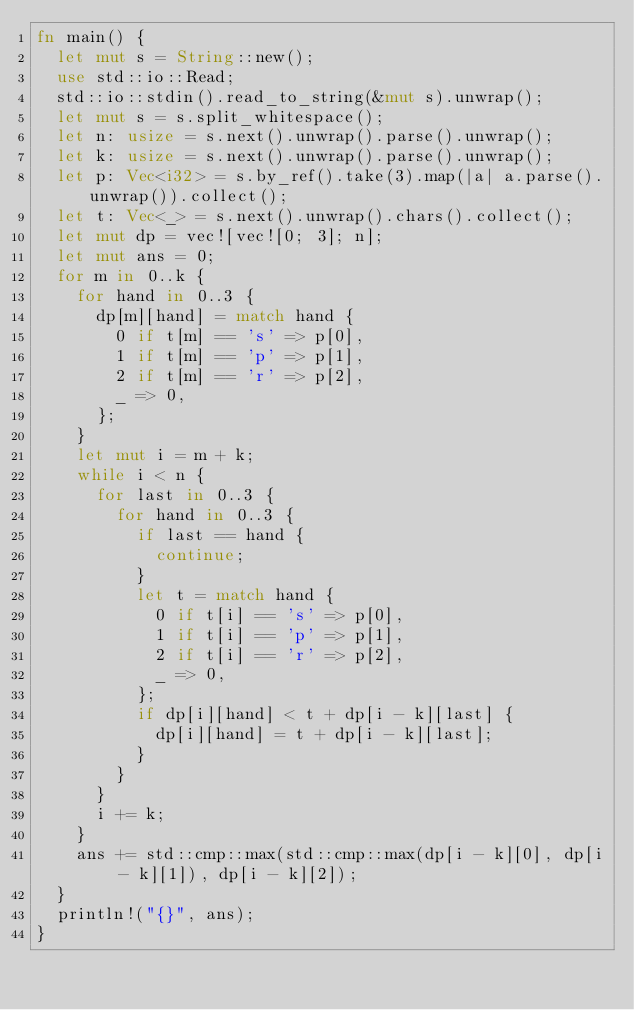Convert code to text. <code><loc_0><loc_0><loc_500><loc_500><_Rust_>fn main() {
	let mut s = String::new();
	use std::io::Read;
	std::io::stdin().read_to_string(&mut s).unwrap();
	let mut s = s.split_whitespace();
	let n: usize = s.next().unwrap().parse().unwrap();
	let k: usize = s.next().unwrap().parse().unwrap();
	let p: Vec<i32> = s.by_ref().take(3).map(|a| a.parse().unwrap()).collect();
	let t: Vec<_> = s.next().unwrap().chars().collect();
	let mut dp = vec![vec![0; 3]; n];
	let mut ans = 0;
	for m in 0..k {
		for hand in 0..3 {
			dp[m][hand] = match hand {
				0 if t[m] == 's' => p[0],
				1 if t[m] == 'p' => p[1],
				2 if t[m] == 'r' => p[2],
				_ => 0,
			};
		}
		let mut i = m + k;
		while i < n {
			for last in 0..3 {
				for hand in 0..3 {
					if last == hand {
						continue;
					}
					let t = match hand {
						0 if t[i] == 's' => p[0],
						1 if t[i] == 'p' => p[1],
						2 if t[i] == 'r' => p[2],
						_ => 0,
					};
					if dp[i][hand] < t + dp[i - k][last] {
						dp[i][hand] = t + dp[i - k][last];
					}
				}
			}
			i += k;
		}
		ans += std::cmp::max(std::cmp::max(dp[i - k][0], dp[i - k][1]), dp[i - k][2]);
	}
	println!("{}", ans);
}
</code> 